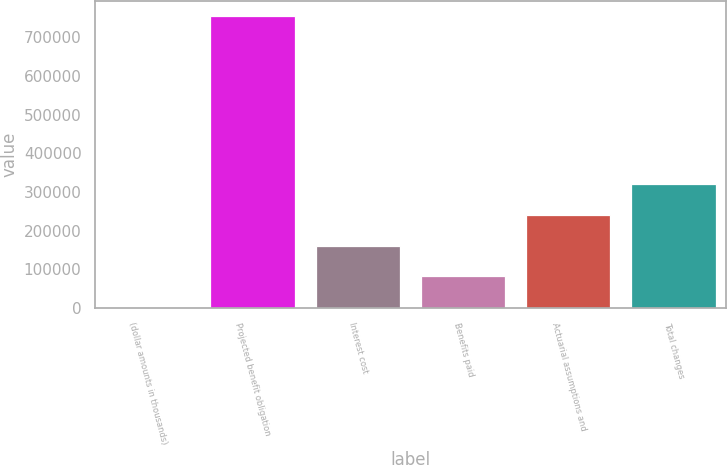Convert chart. <chart><loc_0><loc_0><loc_500><loc_500><bar_chart><fcel>(dollar amounts in thousands)<fcel>Projected benefit obligation<fcel>Interest cost<fcel>Benefits paid<fcel>Actuarial assumptions and<fcel>Total changes<nl><fcel>2015<fcel>754714<fcel>161531<fcel>81772.9<fcel>241289<fcel>321047<nl></chart> 